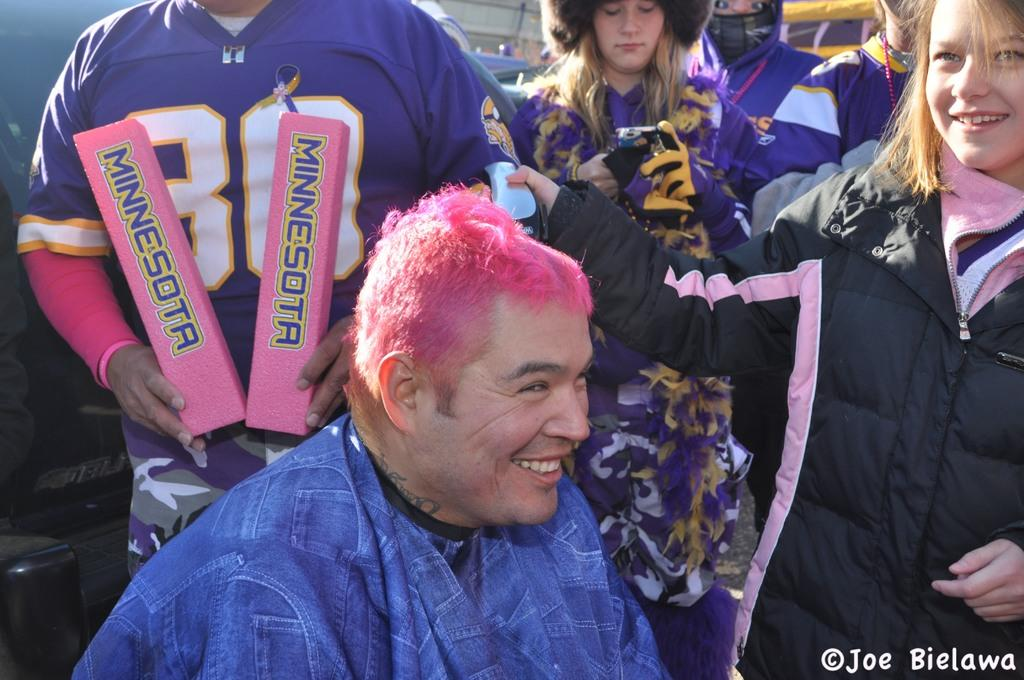<image>
Offer a succinct explanation of the picture presented. Pink haired heavy set Minnesota fan smiling as a girl gives him a buzz cut. 